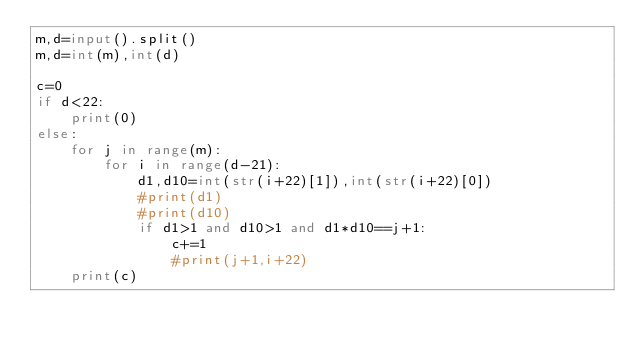<code> <loc_0><loc_0><loc_500><loc_500><_Python_>m,d=input().split()
m,d=int(m),int(d)

c=0
if d<22:
    print(0)
else:
    for j in range(m):
        for i in range(d-21):
            d1,d10=int(str(i+22)[1]),int(str(i+22)[0])
            #print(d1)
            #print(d10)
            if d1>1 and d10>1 and d1*d10==j+1:
                c+=1
                #print(j+1,i+22)
    print(c)
</code> 